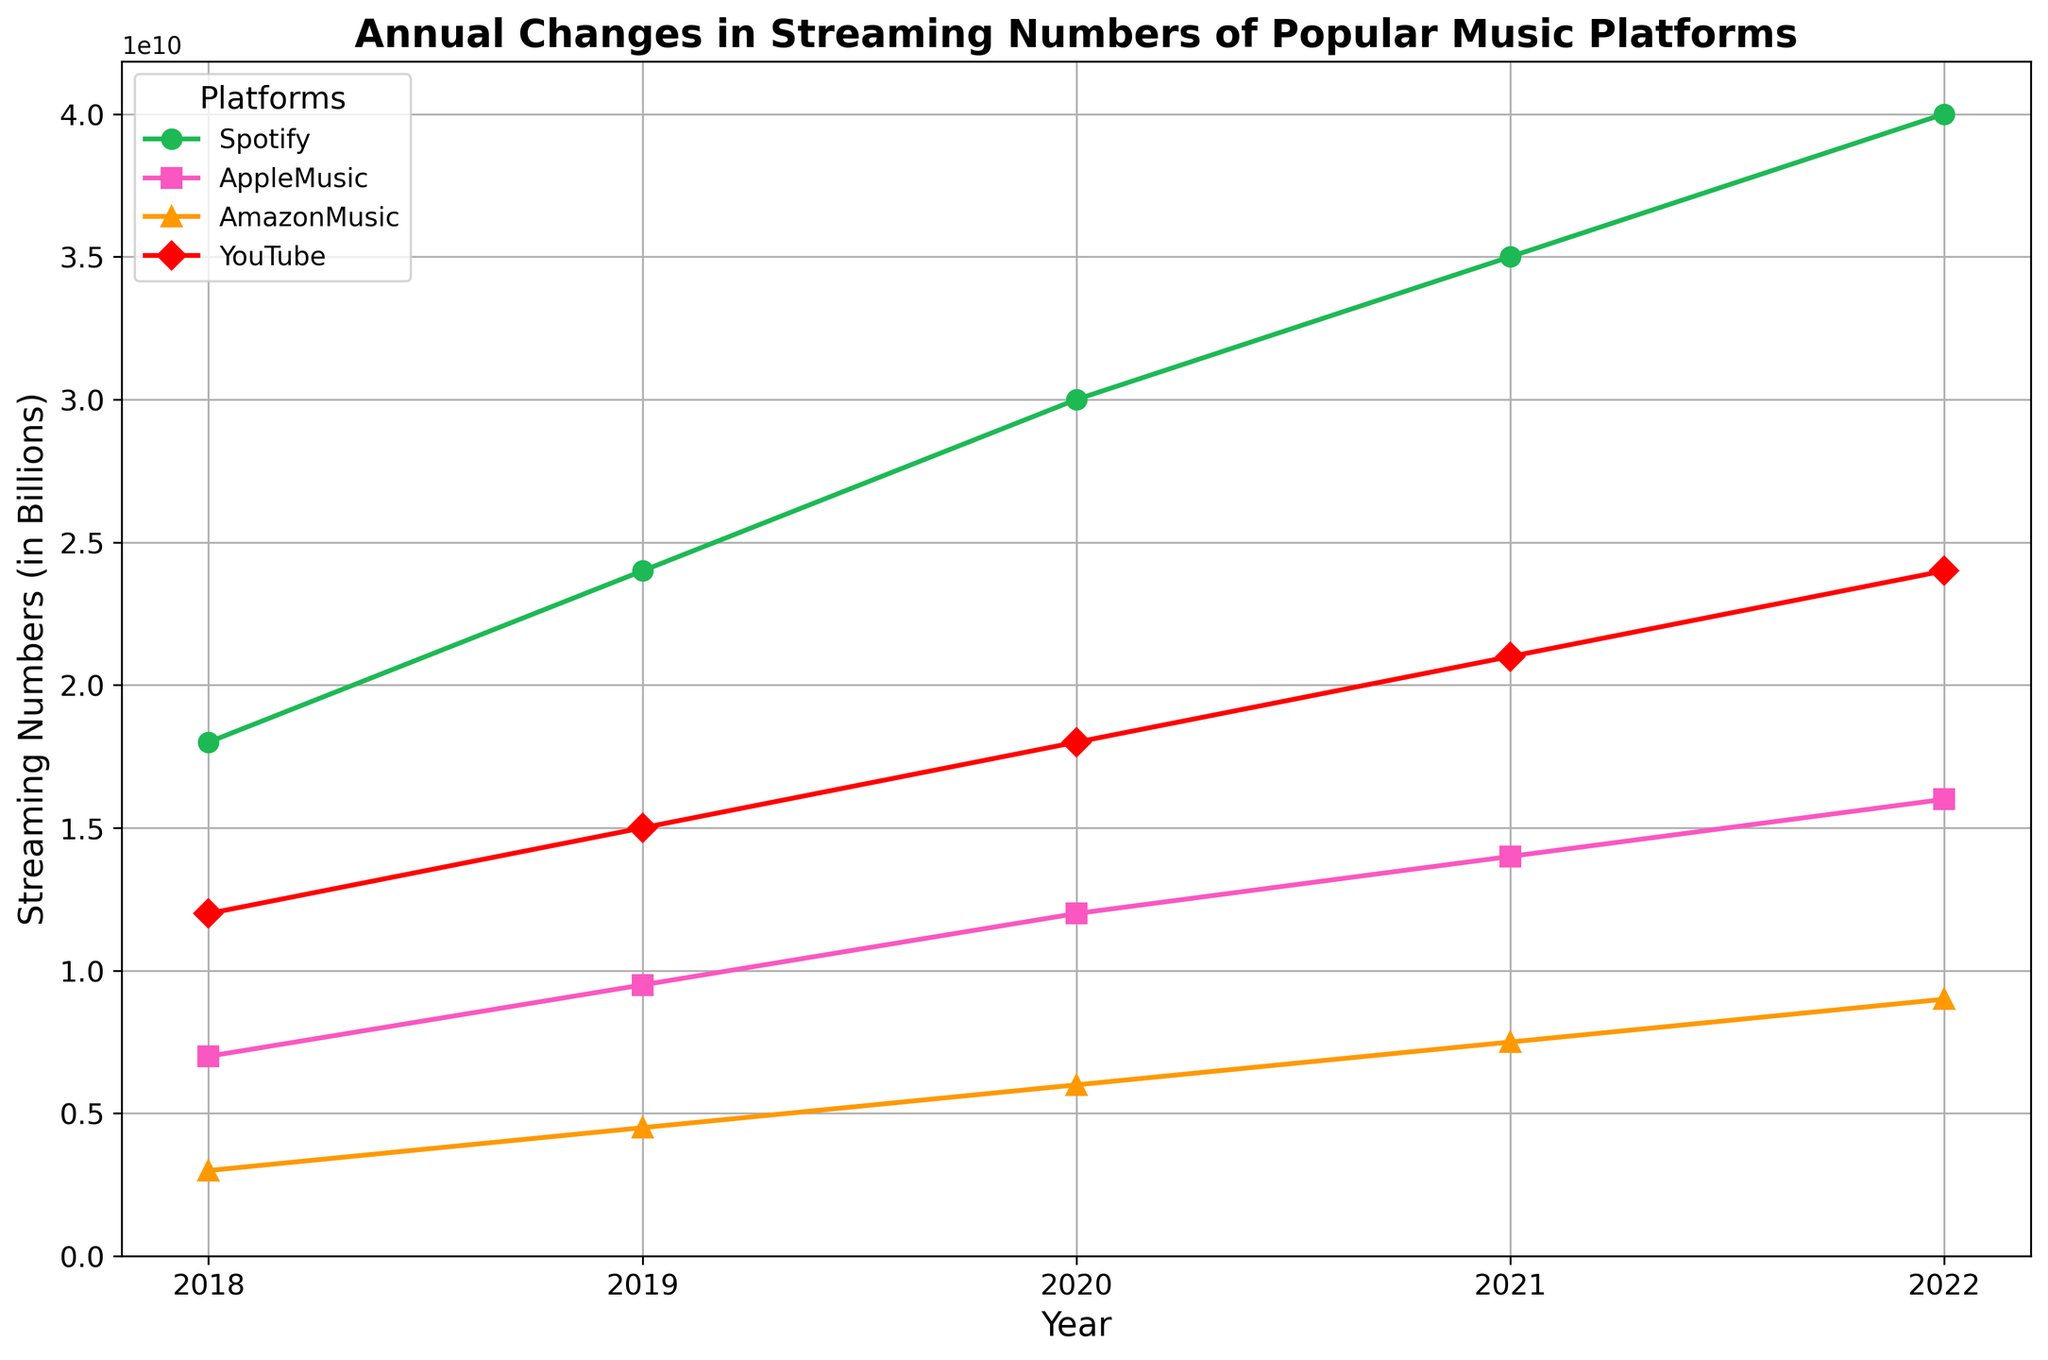How much did Spotify's streaming numbers increase from 2018 to 2022? To find this, subtract the streaming numbers in 2018 from those in 2022. Thus, 40000000000 - 18000000000 = 22000000000.
Answer: 22000000000 Which platform had the highest streaming numbers in 2021, and what were they? By looking at the 2021 data point, find the highest value among Spotify, Apple Music, Amazon Music, and YouTube. The highest streaming numbers were for Spotify with 35000000000.
Answer: Spotify, 35000000000 Compare the growth of Apple Music and Amazon Music between 2019 and 2020. Which one had a higher increase, and by how much? Calculate the increase for each platform from 2019 to 2020: Apple Music (12000000000 - 9500000000 = 2500000000) and Amazon Music (6000000000 - 4500000000 = 1500000000). Compare the two: 2500000000 - 1500000000 = 1000000000. Apple Music had a higher increase by 1000000000.
Answer: Apple Music, 1000000000 What was the total streaming number for all platforms combined in 2020? Sum the 2020 streaming numbers for all platforms: 30000000000 (Spotify) + 12000000000 (Apple Music) + 6000000000 (Amazon Music) + 18000000000 (YouTube) = 66000000000.
Answer: 66000000000 Which year did YouTube have the smallest increase in streaming numbers compared to the previous year, and what was the increase amount? Calculate the yearly increases: 2019-2018 (15000000000 - 12000000000 = 3000000000), 2020-2019 (18000000000 - 15000000000 = 3000000000), 2021-2020 (21000000000 - 18000000000 = 3000000000), and 2022-2021 (24000000000 - 21000000000 = 3000000000). The smallest increase was in any year with a 3000000000 increase since it is consistent.
Answer: Between any consecutive years, 3000000000 What is the average annual increase in streaming numbers for Spotify from 2018 to 2022? Calculate each year's increase: 2019 (24000000000 - 18000000000 = 6000000000), 2020 (30000000000 - 24000000000 = 6000000000), 2021 (35000000000 - 30000000000 = 5000000000), 2022 (40000000000 - 35000000000 = 5000000000). Average these increases: (6000000000 + 6000000000 + 5000000000 + 5000000000) / 4 = 5500000000.
Answer: 5500000000 Which platform shows consistent growth in terms of streaming numbers every year from 2018 to 2022? Inspect the graph and note the platforms whose lines steadily increase each year. All four platforms (Spotify, Apple Music, Amazon Music, and YouTube) show consistent growth in the provided data.
Answer: Spotify, Apple Music, Amazon Music, YouTube 